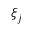<formula> <loc_0><loc_0><loc_500><loc_500>\xi _ { j }</formula> 